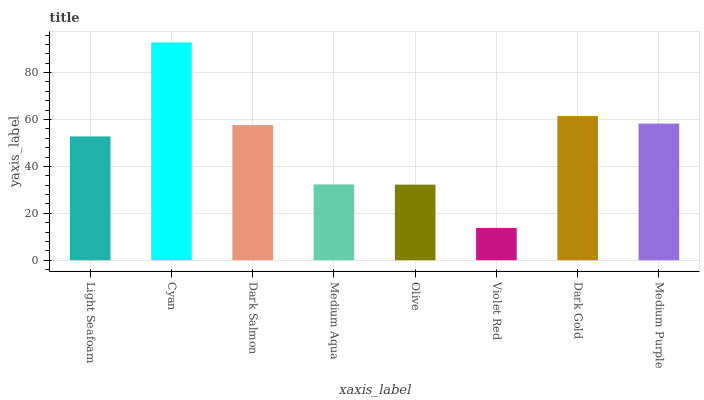Is Violet Red the minimum?
Answer yes or no. Yes. Is Cyan the maximum?
Answer yes or no. Yes. Is Dark Salmon the minimum?
Answer yes or no. No. Is Dark Salmon the maximum?
Answer yes or no. No. Is Cyan greater than Dark Salmon?
Answer yes or no. Yes. Is Dark Salmon less than Cyan?
Answer yes or no. Yes. Is Dark Salmon greater than Cyan?
Answer yes or no. No. Is Cyan less than Dark Salmon?
Answer yes or no. No. Is Dark Salmon the high median?
Answer yes or no. Yes. Is Light Seafoam the low median?
Answer yes or no. Yes. Is Medium Aqua the high median?
Answer yes or no. No. Is Cyan the low median?
Answer yes or no. No. 